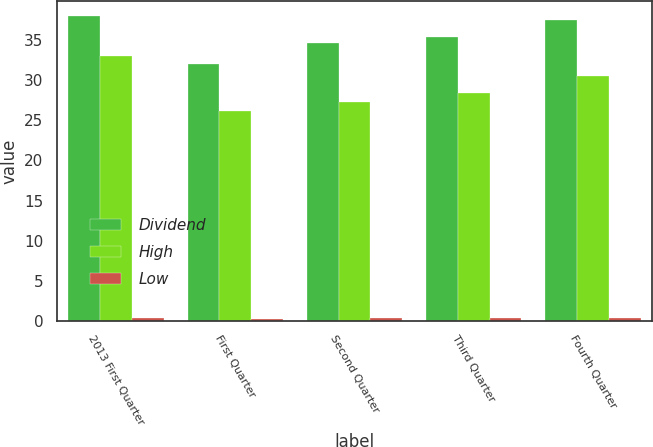Convert chart. <chart><loc_0><loc_0><loc_500><loc_500><stacked_bar_chart><ecel><fcel>2013 First Quarter<fcel>First Quarter<fcel>Second Quarter<fcel>Third Quarter<fcel>Fourth Quarter<nl><fcel>Dividend<fcel>38<fcel>32.09<fcel>34.63<fcel>35.39<fcel>37.56<nl><fcel>High<fcel>33.09<fcel>26.21<fcel>27.25<fcel>28.47<fcel>30.55<nl><fcel>Low<fcel>0.34<fcel>0.26<fcel>0.3<fcel>0.31<fcel>0.33<nl></chart> 